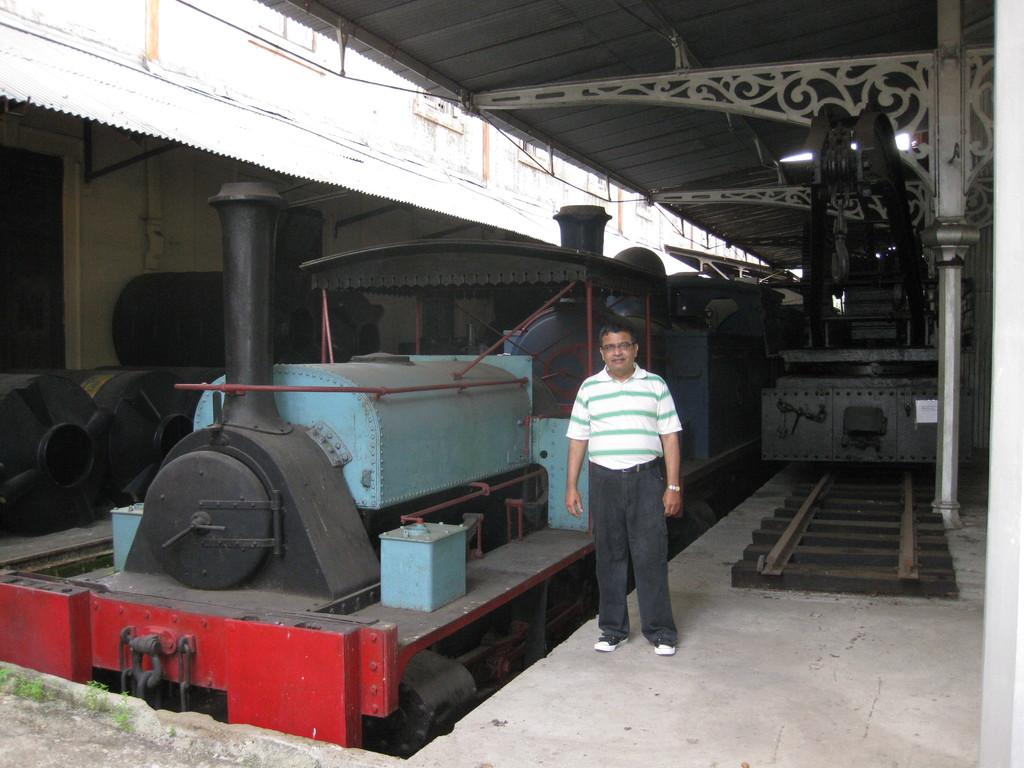What is the main subject of the image? There is a train in the image. What can be seen on the right side of the image? There is a track on the right side of the image. Who is present in the image? There is a man standing in the center of the image. What is visible at the top of the image? There is a roof visible at the top of the image. What is in the background of the image? There is a wall in the background of the image. What type of yam is being used as a volleyball in the image? There is no yam or volleyball present in the image. What is the man's tongue doing in the image? The man's tongue is not visible or mentioned in the image, so it cannot be determined what it is doing. 